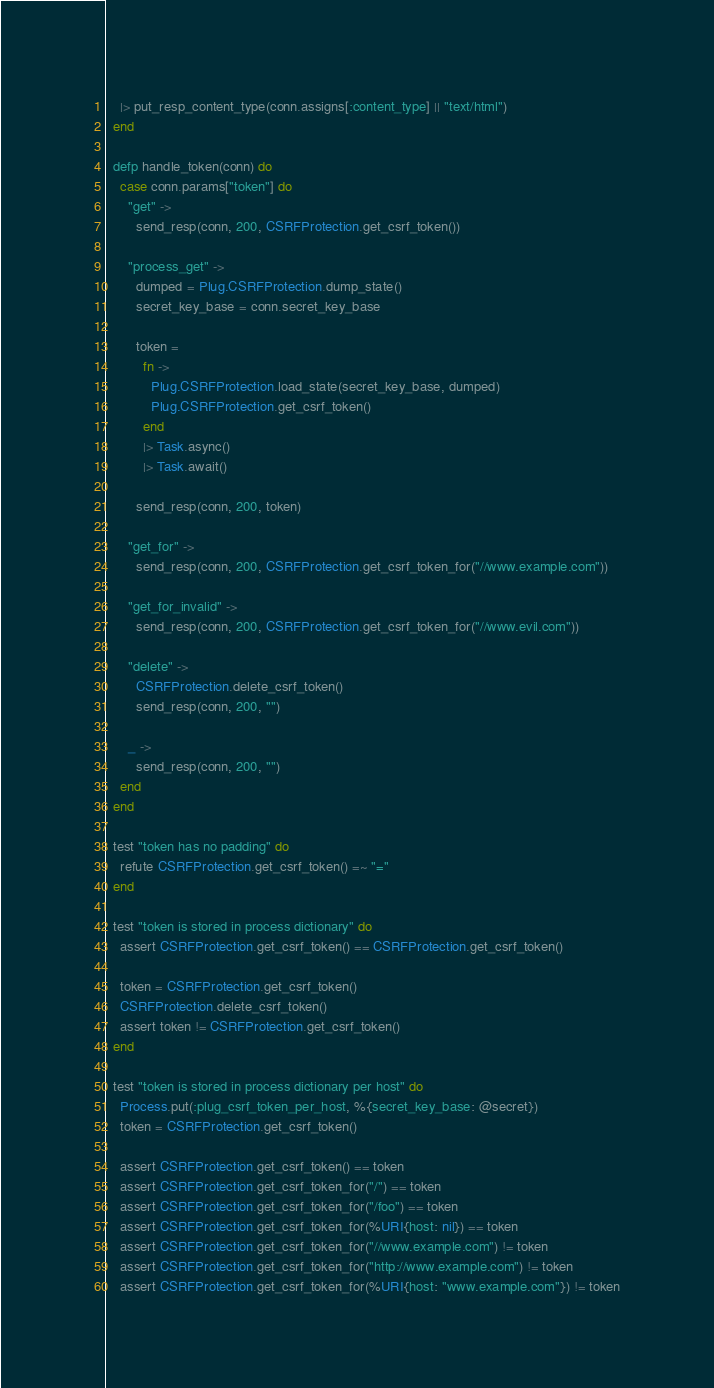Convert code to text. <code><loc_0><loc_0><loc_500><loc_500><_Elixir_>    |> put_resp_content_type(conn.assigns[:content_type] || "text/html")
  end

  defp handle_token(conn) do
    case conn.params["token"] do
      "get" ->
        send_resp(conn, 200, CSRFProtection.get_csrf_token())

      "process_get" ->
        dumped = Plug.CSRFProtection.dump_state()
        secret_key_base = conn.secret_key_base

        token =
          fn ->
            Plug.CSRFProtection.load_state(secret_key_base, dumped)
            Plug.CSRFProtection.get_csrf_token()
          end
          |> Task.async()
          |> Task.await()

        send_resp(conn, 200, token)

      "get_for" ->
        send_resp(conn, 200, CSRFProtection.get_csrf_token_for("//www.example.com"))

      "get_for_invalid" ->
        send_resp(conn, 200, CSRFProtection.get_csrf_token_for("//www.evil.com"))

      "delete" ->
        CSRFProtection.delete_csrf_token()
        send_resp(conn, 200, "")

      _ ->
        send_resp(conn, 200, "")
    end
  end

  test "token has no padding" do
    refute CSRFProtection.get_csrf_token() =~ "="
  end

  test "token is stored in process dictionary" do
    assert CSRFProtection.get_csrf_token() == CSRFProtection.get_csrf_token()

    token = CSRFProtection.get_csrf_token()
    CSRFProtection.delete_csrf_token()
    assert token != CSRFProtection.get_csrf_token()
  end

  test "token is stored in process dictionary per host" do
    Process.put(:plug_csrf_token_per_host, %{secret_key_base: @secret})
    token = CSRFProtection.get_csrf_token()

    assert CSRFProtection.get_csrf_token() == token
    assert CSRFProtection.get_csrf_token_for("/") == token
    assert CSRFProtection.get_csrf_token_for("/foo") == token
    assert CSRFProtection.get_csrf_token_for(%URI{host: nil}) == token
    assert CSRFProtection.get_csrf_token_for("//www.example.com") != token
    assert CSRFProtection.get_csrf_token_for("http://www.example.com") != token
    assert CSRFProtection.get_csrf_token_for(%URI{host: "www.example.com"}) != token
</code> 